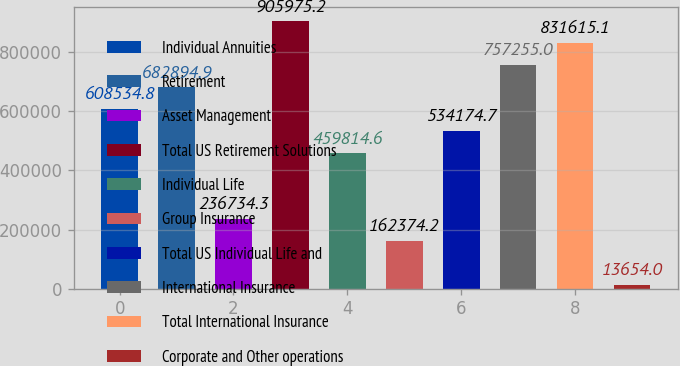<chart> <loc_0><loc_0><loc_500><loc_500><bar_chart><fcel>Individual Annuities<fcel>Retirement<fcel>Asset Management<fcel>Total US Retirement Solutions<fcel>Individual Life<fcel>Group Insurance<fcel>Total US Individual Life and<fcel>International Insurance<fcel>Total International Insurance<fcel>Corporate and Other operations<nl><fcel>608535<fcel>682895<fcel>236734<fcel>905975<fcel>459815<fcel>162374<fcel>534175<fcel>757255<fcel>831615<fcel>13654<nl></chart> 